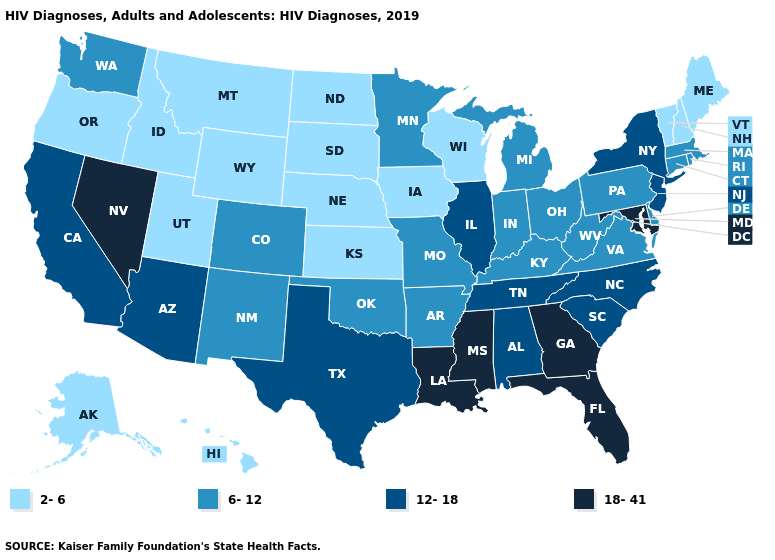Among the states that border South Carolina , which have the lowest value?
Give a very brief answer. North Carolina. What is the value of Nevada?
Quick response, please. 18-41. What is the value of New Jersey?
Concise answer only. 12-18. Does the first symbol in the legend represent the smallest category?
Short answer required. Yes. How many symbols are there in the legend?
Short answer required. 4. Does Arkansas have the same value as Wisconsin?
Quick response, please. No. Does Montana have a lower value than North Dakota?
Concise answer only. No. Does the first symbol in the legend represent the smallest category?
Be succinct. Yes. What is the value of Connecticut?
Quick response, please. 6-12. Name the states that have a value in the range 12-18?
Give a very brief answer. Alabama, Arizona, California, Illinois, New Jersey, New York, North Carolina, South Carolina, Tennessee, Texas. Name the states that have a value in the range 2-6?
Quick response, please. Alaska, Hawaii, Idaho, Iowa, Kansas, Maine, Montana, Nebraska, New Hampshire, North Dakota, Oregon, South Dakota, Utah, Vermont, Wisconsin, Wyoming. What is the value of South Dakota?
Be succinct. 2-6. Name the states that have a value in the range 12-18?
Short answer required. Alabama, Arizona, California, Illinois, New Jersey, New York, North Carolina, South Carolina, Tennessee, Texas. Among the states that border South Carolina , does North Carolina have the lowest value?
Answer briefly. Yes. Does Utah have the lowest value in the West?
Keep it brief. Yes. 